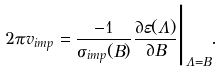<formula> <loc_0><loc_0><loc_500><loc_500>2 \pi v _ { i m p } = \frac { - 1 } { \sigma _ { i m p } ( B ) } \frac { \partial \varepsilon ( \Lambda ) } { \partial B } \Big | _ { \Lambda = B } \Big . .</formula> 